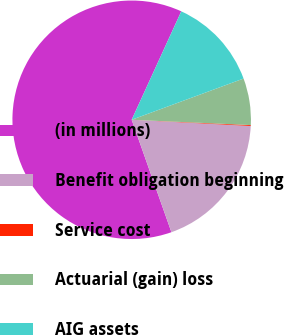Convert chart. <chart><loc_0><loc_0><loc_500><loc_500><pie_chart><fcel>(in millions)<fcel>Benefit obligation beginning<fcel>Service cost<fcel>Actuarial (gain) loss<fcel>AIG assets<nl><fcel>62.24%<fcel>18.76%<fcel>0.12%<fcel>6.33%<fcel>12.55%<nl></chart> 